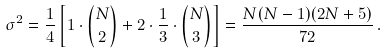Convert formula to latex. <formula><loc_0><loc_0><loc_500><loc_500>\sigma ^ { 2 } = \frac { 1 } { 4 } \left [ 1 \cdot { N \choose 2 } + 2 \cdot \frac { 1 } { 3 } \cdot { N \choose 3 } \right ] = \frac { N ( N - 1 ) ( 2 N + 5 ) } { 7 2 } \, .</formula> 